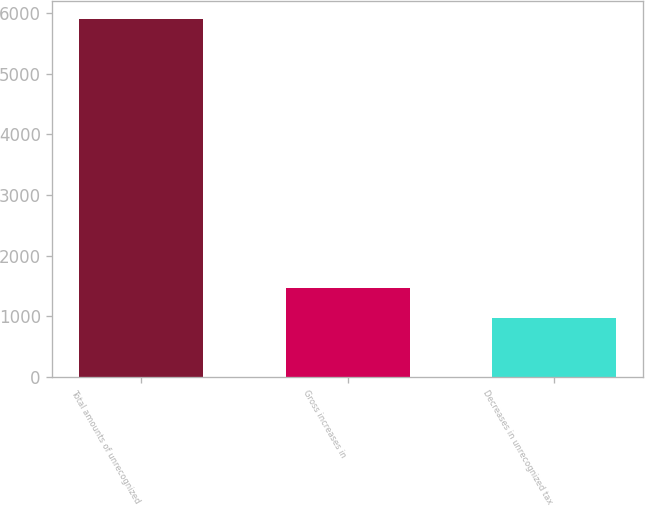Convert chart to OTSL. <chart><loc_0><loc_0><loc_500><loc_500><bar_chart><fcel>Total amounts of unrecognized<fcel>Gross increases in<fcel>Decreases in unrecognized tax<nl><fcel>5906<fcel>1462.7<fcel>969<nl></chart> 